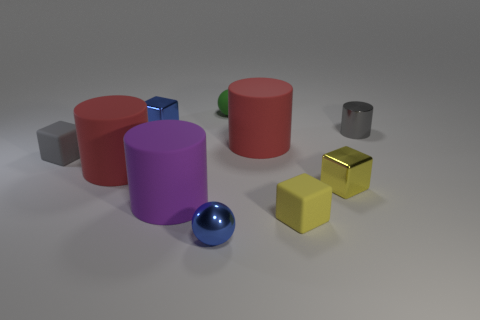Is there a small object of the same color as the tiny metallic sphere?
Provide a succinct answer. Yes. What number of large gray cylinders are the same material as the small gray cube?
Your answer should be very brief. 0. There is a tiny green ball; how many tiny blocks are behind it?
Ensure brevity in your answer.  0. Is the material of the yellow block in front of the large purple cylinder the same as the green ball that is behind the small gray rubber object?
Keep it short and to the point. Yes. Are there more small blue things that are left of the purple object than tiny yellow metal blocks that are to the right of the tiny gray cylinder?
Make the answer very short. Yes. There is a tiny object that is the same color as the small shiny ball; what material is it?
Offer a terse response. Metal. What is the material of the tiny thing that is on the left side of the large purple rubber object and behind the metal cylinder?
Offer a terse response. Metal. Does the green ball have the same material as the gray thing that is to the right of the shiny ball?
Provide a succinct answer. No. What number of objects are yellow rubber cubes or tiny gray cylinders on the right side of the blue shiny ball?
Offer a very short reply. 2. There is a red cylinder that is to the left of the large purple object; is it the same size as the red cylinder on the right side of the blue block?
Provide a short and direct response. Yes. 